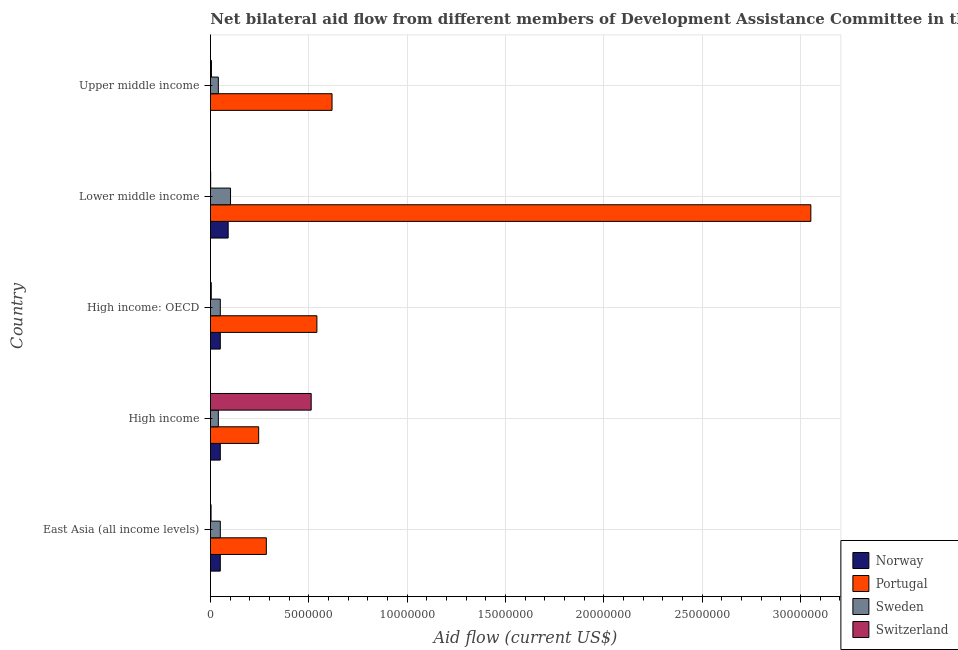Are the number of bars on each tick of the Y-axis equal?
Provide a short and direct response. No. What is the label of the 1st group of bars from the top?
Provide a short and direct response. Upper middle income. What is the amount of aid given by norway in East Asia (all income levels)?
Ensure brevity in your answer.  5.00e+05. Across all countries, what is the maximum amount of aid given by norway?
Your answer should be compact. 9.00e+05. Across all countries, what is the minimum amount of aid given by portugal?
Ensure brevity in your answer.  2.45e+06. In which country was the amount of aid given by sweden maximum?
Your answer should be compact. Lower middle income. What is the total amount of aid given by switzerland in the graph?
Ensure brevity in your answer.  5.25e+06. What is the difference between the amount of aid given by switzerland in East Asia (all income levels) and that in Upper middle income?
Keep it short and to the point. -2.00e+04. What is the difference between the amount of aid given by portugal in East Asia (all income levels) and the amount of aid given by sweden in Lower middle income?
Provide a succinct answer. 1.82e+06. What is the average amount of aid given by portugal per country?
Offer a very short reply. 9.48e+06. What is the difference between the amount of aid given by switzerland and amount of aid given by portugal in Upper middle income?
Your answer should be compact. -6.13e+06. What is the ratio of the amount of aid given by sweden in Lower middle income to that in Upper middle income?
Keep it short and to the point. 2.55. What is the difference between the highest and the second highest amount of aid given by norway?
Provide a short and direct response. 4.00e+05. What is the difference between the highest and the lowest amount of aid given by sweden?
Offer a terse response. 6.20e+05. Is the sum of the amount of aid given by switzerland in Lower middle income and Upper middle income greater than the maximum amount of aid given by sweden across all countries?
Provide a succinct answer. No. Is it the case that in every country, the sum of the amount of aid given by norway and amount of aid given by portugal is greater than the amount of aid given by sweden?
Give a very brief answer. Yes. What is the difference between two consecutive major ticks on the X-axis?
Give a very brief answer. 5.00e+06. Are the values on the major ticks of X-axis written in scientific E-notation?
Give a very brief answer. No. Does the graph contain any zero values?
Provide a short and direct response. Yes. How many legend labels are there?
Make the answer very short. 4. How are the legend labels stacked?
Offer a very short reply. Vertical. What is the title of the graph?
Your answer should be compact. Net bilateral aid flow from different members of Development Assistance Committee in the year 1961. What is the label or title of the X-axis?
Provide a succinct answer. Aid flow (current US$). What is the label or title of the Y-axis?
Your response must be concise. Country. What is the Aid flow (current US$) of Norway in East Asia (all income levels)?
Your answer should be very brief. 5.00e+05. What is the Aid flow (current US$) in Portugal in East Asia (all income levels)?
Make the answer very short. 2.84e+06. What is the Aid flow (current US$) in Sweden in East Asia (all income levels)?
Ensure brevity in your answer.  5.00e+05. What is the Aid flow (current US$) of Switzerland in East Asia (all income levels)?
Keep it short and to the point. 3.00e+04. What is the Aid flow (current US$) in Portugal in High income?
Your response must be concise. 2.45e+06. What is the Aid flow (current US$) of Sweden in High income?
Your answer should be compact. 4.00e+05. What is the Aid flow (current US$) of Switzerland in High income?
Give a very brief answer. 5.12e+06. What is the Aid flow (current US$) in Norway in High income: OECD?
Provide a succinct answer. 5.00e+05. What is the Aid flow (current US$) of Portugal in High income: OECD?
Your answer should be compact. 5.41e+06. What is the Aid flow (current US$) of Norway in Lower middle income?
Ensure brevity in your answer.  9.00e+05. What is the Aid flow (current US$) of Portugal in Lower middle income?
Make the answer very short. 3.05e+07. What is the Aid flow (current US$) of Sweden in Lower middle income?
Make the answer very short. 1.02e+06. What is the Aid flow (current US$) of Switzerland in Lower middle income?
Offer a very short reply. 10000. What is the Aid flow (current US$) of Norway in Upper middle income?
Offer a terse response. 0. What is the Aid flow (current US$) of Portugal in Upper middle income?
Offer a very short reply. 6.18e+06. What is the Aid flow (current US$) in Switzerland in Upper middle income?
Your answer should be very brief. 5.00e+04. Across all countries, what is the maximum Aid flow (current US$) in Portugal?
Provide a short and direct response. 3.05e+07. Across all countries, what is the maximum Aid flow (current US$) in Sweden?
Provide a succinct answer. 1.02e+06. Across all countries, what is the maximum Aid flow (current US$) of Switzerland?
Provide a short and direct response. 5.12e+06. Across all countries, what is the minimum Aid flow (current US$) in Norway?
Provide a succinct answer. 0. Across all countries, what is the minimum Aid flow (current US$) of Portugal?
Ensure brevity in your answer.  2.45e+06. What is the total Aid flow (current US$) in Norway in the graph?
Provide a succinct answer. 2.40e+06. What is the total Aid flow (current US$) of Portugal in the graph?
Provide a short and direct response. 4.74e+07. What is the total Aid flow (current US$) of Sweden in the graph?
Keep it short and to the point. 2.82e+06. What is the total Aid flow (current US$) in Switzerland in the graph?
Keep it short and to the point. 5.25e+06. What is the difference between the Aid flow (current US$) of Norway in East Asia (all income levels) and that in High income?
Make the answer very short. 0. What is the difference between the Aid flow (current US$) of Sweden in East Asia (all income levels) and that in High income?
Your response must be concise. 1.00e+05. What is the difference between the Aid flow (current US$) in Switzerland in East Asia (all income levels) and that in High income?
Ensure brevity in your answer.  -5.09e+06. What is the difference between the Aid flow (current US$) of Norway in East Asia (all income levels) and that in High income: OECD?
Your answer should be compact. 0. What is the difference between the Aid flow (current US$) of Portugal in East Asia (all income levels) and that in High income: OECD?
Provide a short and direct response. -2.57e+06. What is the difference between the Aid flow (current US$) in Switzerland in East Asia (all income levels) and that in High income: OECD?
Your answer should be very brief. -10000. What is the difference between the Aid flow (current US$) of Norway in East Asia (all income levels) and that in Lower middle income?
Provide a succinct answer. -4.00e+05. What is the difference between the Aid flow (current US$) in Portugal in East Asia (all income levels) and that in Lower middle income?
Keep it short and to the point. -2.77e+07. What is the difference between the Aid flow (current US$) of Sweden in East Asia (all income levels) and that in Lower middle income?
Your answer should be very brief. -5.20e+05. What is the difference between the Aid flow (current US$) of Switzerland in East Asia (all income levels) and that in Lower middle income?
Provide a succinct answer. 2.00e+04. What is the difference between the Aid flow (current US$) in Portugal in East Asia (all income levels) and that in Upper middle income?
Offer a terse response. -3.34e+06. What is the difference between the Aid flow (current US$) of Sweden in East Asia (all income levels) and that in Upper middle income?
Keep it short and to the point. 1.00e+05. What is the difference between the Aid flow (current US$) of Norway in High income and that in High income: OECD?
Give a very brief answer. 0. What is the difference between the Aid flow (current US$) in Portugal in High income and that in High income: OECD?
Offer a very short reply. -2.96e+06. What is the difference between the Aid flow (current US$) in Switzerland in High income and that in High income: OECD?
Offer a terse response. 5.08e+06. What is the difference between the Aid flow (current US$) in Norway in High income and that in Lower middle income?
Your answer should be compact. -4.00e+05. What is the difference between the Aid flow (current US$) of Portugal in High income and that in Lower middle income?
Give a very brief answer. -2.81e+07. What is the difference between the Aid flow (current US$) of Sweden in High income and that in Lower middle income?
Your response must be concise. -6.20e+05. What is the difference between the Aid flow (current US$) of Switzerland in High income and that in Lower middle income?
Give a very brief answer. 5.11e+06. What is the difference between the Aid flow (current US$) in Portugal in High income and that in Upper middle income?
Keep it short and to the point. -3.73e+06. What is the difference between the Aid flow (current US$) in Switzerland in High income and that in Upper middle income?
Provide a succinct answer. 5.07e+06. What is the difference between the Aid flow (current US$) in Norway in High income: OECD and that in Lower middle income?
Provide a short and direct response. -4.00e+05. What is the difference between the Aid flow (current US$) of Portugal in High income: OECD and that in Lower middle income?
Your answer should be very brief. -2.51e+07. What is the difference between the Aid flow (current US$) of Sweden in High income: OECD and that in Lower middle income?
Provide a succinct answer. -5.20e+05. What is the difference between the Aid flow (current US$) in Switzerland in High income: OECD and that in Lower middle income?
Your response must be concise. 3.00e+04. What is the difference between the Aid flow (current US$) of Portugal in High income: OECD and that in Upper middle income?
Offer a terse response. -7.70e+05. What is the difference between the Aid flow (current US$) of Portugal in Lower middle income and that in Upper middle income?
Your answer should be very brief. 2.43e+07. What is the difference between the Aid flow (current US$) in Sweden in Lower middle income and that in Upper middle income?
Your answer should be compact. 6.20e+05. What is the difference between the Aid flow (current US$) of Switzerland in Lower middle income and that in Upper middle income?
Provide a short and direct response. -4.00e+04. What is the difference between the Aid flow (current US$) of Norway in East Asia (all income levels) and the Aid flow (current US$) of Portugal in High income?
Keep it short and to the point. -1.95e+06. What is the difference between the Aid flow (current US$) of Norway in East Asia (all income levels) and the Aid flow (current US$) of Switzerland in High income?
Make the answer very short. -4.62e+06. What is the difference between the Aid flow (current US$) of Portugal in East Asia (all income levels) and the Aid flow (current US$) of Sweden in High income?
Offer a very short reply. 2.44e+06. What is the difference between the Aid flow (current US$) in Portugal in East Asia (all income levels) and the Aid flow (current US$) in Switzerland in High income?
Your answer should be very brief. -2.28e+06. What is the difference between the Aid flow (current US$) of Sweden in East Asia (all income levels) and the Aid flow (current US$) of Switzerland in High income?
Your answer should be compact. -4.62e+06. What is the difference between the Aid flow (current US$) in Norway in East Asia (all income levels) and the Aid flow (current US$) in Portugal in High income: OECD?
Offer a very short reply. -4.91e+06. What is the difference between the Aid flow (current US$) of Norway in East Asia (all income levels) and the Aid flow (current US$) of Sweden in High income: OECD?
Make the answer very short. 0. What is the difference between the Aid flow (current US$) in Norway in East Asia (all income levels) and the Aid flow (current US$) in Switzerland in High income: OECD?
Your answer should be very brief. 4.60e+05. What is the difference between the Aid flow (current US$) of Portugal in East Asia (all income levels) and the Aid flow (current US$) of Sweden in High income: OECD?
Keep it short and to the point. 2.34e+06. What is the difference between the Aid flow (current US$) of Portugal in East Asia (all income levels) and the Aid flow (current US$) of Switzerland in High income: OECD?
Keep it short and to the point. 2.80e+06. What is the difference between the Aid flow (current US$) of Norway in East Asia (all income levels) and the Aid flow (current US$) of Portugal in Lower middle income?
Provide a short and direct response. -3.00e+07. What is the difference between the Aid flow (current US$) in Norway in East Asia (all income levels) and the Aid flow (current US$) in Sweden in Lower middle income?
Make the answer very short. -5.20e+05. What is the difference between the Aid flow (current US$) of Norway in East Asia (all income levels) and the Aid flow (current US$) of Switzerland in Lower middle income?
Provide a short and direct response. 4.90e+05. What is the difference between the Aid flow (current US$) in Portugal in East Asia (all income levels) and the Aid flow (current US$) in Sweden in Lower middle income?
Give a very brief answer. 1.82e+06. What is the difference between the Aid flow (current US$) in Portugal in East Asia (all income levels) and the Aid flow (current US$) in Switzerland in Lower middle income?
Keep it short and to the point. 2.83e+06. What is the difference between the Aid flow (current US$) in Sweden in East Asia (all income levels) and the Aid flow (current US$) in Switzerland in Lower middle income?
Your response must be concise. 4.90e+05. What is the difference between the Aid flow (current US$) in Norway in East Asia (all income levels) and the Aid flow (current US$) in Portugal in Upper middle income?
Give a very brief answer. -5.68e+06. What is the difference between the Aid flow (current US$) in Portugal in East Asia (all income levels) and the Aid flow (current US$) in Sweden in Upper middle income?
Your answer should be very brief. 2.44e+06. What is the difference between the Aid flow (current US$) of Portugal in East Asia (all income levels) and the Aid flow (current US$) of Switzerland in Upper middle income?
Offer a very short reply. 2.79e+06. What is the difference between the Aid flow (current US$) in Norway in High income and the Aid flow (current US$) in Portugal in High income: OECD?
Make the answer very short. -4.91e+06. What is the difference between the Aid flow (current US$) of Norway in High income and the Aid flow (current US$) of Sweden in High income: OECD?
Give a very brief answer. 0. What is the difference between the Aid flow (current US$) in Norway in High income and the Aid flow (current US$) in Switzerland in High income: OECD?
Provide a succinct answer. 4.60e+05. What is the difference between the Aid flow (current US$) of Portugal in High income and the Aid flow (current US$) of Sweden in High income: OECD?
Provide a short and direct response. 1.95e+06. What is the difference between the Aid flow (current US$) of Portugal in High income and the Aid flow (current US$) of Switzerland in High income: OECD?
Offer a very short reply. 2.41e+06. What is the difference between the Aid flow (current US$) in Norway in High income and the Aid flow (current US$) in Portugal in Lower middle income?
Ensure brevity in your answer.  -3.00e+07. What is the difference between the Aid flow (current US$) in Norway in High income and the Aid flow (current US$) in Sweden in Lower middle income?
Keep it short and to the point. -5.20e+05. What is the difference between the Aid flow (current US$) of Norway in High income and the Aid flow (current US$) of Switzerland in Lower middle income?
Your answer should be very brief. 4.90e+05. What is the difference between the Aid flow (current US$) in Portugal in High income and the Aid flow (current US$) in Sweden in Lower middle income?
Provide a short and direct response. 1.43e+06. What is the difference between the Aid flow (current US$) of Portugal in High income and the Aid flow (current US$) of Switzerland in Lower middle income?
Provide a short and direct response. 2.44e+06. What is the difference between the Aid flow (current US$) in Sweden in High income and the Aid flow (current US$) in Switzerland in Lower middle income?
Provide a short and direct response. 3.90e+05. What is the difference between the Aid flow (current US$) in Norway in High income and the Aid flow (current US$) in Portugal in Upper middle income?
Give a very brief answer. -5.68e+06. What is the difference between the Aid flow (current US$) in Norway in High income and the Aid flow (current US$) in Sweden in Upper middle income?
Your response must be concise. 1.00e+05. What is the difference between the Aid flow (current US$) in Norway in High income and the Aid flow (current US$) in Switzerland in Upper middle income?
Your answer should be very brief. 4.50e+05. What is the difference between the Aid flow (current US$) of Portugal in High income and the Aid flow (current US$) of Sweden in Upper middle income?
Your answer should be very brief. 2.05e+06. What is the difference between the Aid flow (current US$) in Portugal in High income and the Aid flow (current US$) in Switzerland in Upper middle income?
Your answer should be compact. 2.40e+06. What is the difference between the Aid flow (current US$) of Sweden in High income and the Aid flow (current US$) of Switzerland in Upper middle income?
Your answer should be very brief. 3.50e+05. What is the difference between the Aid flow (current US$) of Norway in High income: OECD and the Aid flow (current US$) of Portugal in Lower middle income?
Ensure brevity in your answer.  -3.00e+07. What is the difference between the Aid flow (current US$) of Norway in High income: OECD and the Aid flow (current US$) of Sweden in Lower middle income?
Offer a very short reply. -5.20e+05. What is the difference between the Aid flow (current US$) of Portugal in High income: OECD and the Aid flow (current US$) of Sweden in Lower middle income?
Ensure brevity in your answer.  4.39e+06. What is the difference between the Aid flow (current US$) of Portugal in High income: OECD and the Aid flow (current US$) of Switzerland in Lower middle income?
Your answer should be very brief. 5.40e+06. What is the difference between the Aid flow (current US$) of Sweden in High income: OECD and the Aid flow (current US$) of Switzerland in Lower middle income?
Offer a very short reply. 4.90e+05. What is the difference between the Aid flow (current US$) in Norway in High income: OECD and the Aid flow (current US$) in Portugal in Upper middle income?
Keep it short and to the point. -5.68e+06. What is the difference between the Aid flow (current US$) in Norway in High income: OECD and the Aid flow (current US$) in Sweden in Upper middle income?
Your answer should be very brief. 1.00e+05. What is the difference between the Aid flow (current US$) in Portugal in High income: OECD and the Aid flow (current US$) in Sweden in Upper middle income?
Make the answer very short. 5.01e+06. What is the difference between the Aid flow (current US$) in Portugal in High income: OECD and the Aid flow (current US$) in Switzerland in Upper middle income?
Make the answer very short. 5.36e+06. What is the difference between the Aid flow (current US$) in Norway in Lower middle income and the Aid flow (current US$) in Portugal in Upper middle income?
Your response must be concise. -5.28e+06. What is the difference between the Aid flow (current US$) in Norway in Lower middle income and the Aid flow (current US$) in Switzerland in Upper middle income?
Your answer should be compact. 8.50e+05. What is the difference between the Aid flow (current US$) of Portugal in Lower middle income and the Aid flow (current US$) of Sweden in Upper middle income?
Keep it short and to the point. 3.01e+07. What is the difference between the Aid flow (current US$) in Portugal in Lower middle income and the Aid flow (current US$) in Switzerland in Upper middle income?
Provide a short and direct response. 3.05e+07. What is the difference between the Aid flow (current US$) in Sweden in Lower middle income and the Aid flow (current US$) in Switzerland in Upper middle income?
Provide a succinct answer. 9.70e+05. What is the average Aid flow (current US$) in Portugal per country?
Offer a very short reply. 9.48e+06. What is the average Aid flow (current US$) of Sweden per country?
Provide a short and direct response. 5.64e+05. What is the average Aid flow (current US$) of Switzerland per country?
Ensure brevity in your answer.  1.05e+06. What is the difference between the Aid flow (current US$) in Norway and Aid flow (current US$) in Portugal in East Asia (all income levels)?
Make the answer very short. -2.34e+06. What is the difference between the Aid flow (current US$) in Norway and Aid flow (current US$) in Switzerland in East Asia (all income levels)?
Make the answer very short. 4.70e+05. What is the difference between the Aid flow (current US$) of Portugal and Aid flow (current US$) of Sweden in East Asia (all income levels)?
Provide a succinct answer. 2.34e+06. What is the difference between the Aid flow (current US$) in Portugal and Aid flow (current US$) in Switzerland in East Asia (all income levels)?
Your answer should be very brief. 2.81e+06. What is the difference between the Aid flow (current US$) in Sweden and Aid flow (current US$) in Switzerland in East Asia (all income levels)?
Keep it short and to the point. 4.70e+05. What is the difference between the Aid flow (current US$) in Norway and Aid flow (current US$) in Portugal in High income?
Offer a very short reply. -1.95e+06. What is the difference between the Aid flow (current US$) of Norway and Aid flow (current US$) of Switzerland in High income?
Your response must be concise. -4.62e+06. What is the difference between the Aid flow (current US$) of Portugal and Aid flow (current US$) of Sweden in High income?
Your answer should be compact. 2.05e+06. What is the difference between the Aid flow (current US$) in Portugal and Aid flow (current US$) in Switzerland in High income?
Give a very brief answer. -2.67e+06. What is the difference between the Aid flow (current US$) of Sweden and Aid flow (current US$) of Switzerland in High income?
Your answer should be compact. -4.72e+06. What is the difference between the Aid flow (current US$) in Norway and Aid flow (current US$) in Portugal in High income: OECD?
Provide a succinct answer. -4.91e+06. What is the difference between the Aid flow (current US$) of Norway and Aid flow (current US$) of Switzerland in High income: OECD?
Make the answer very short. 4.60e+05. What is the difference between the Aid flow (current US$) in Portugal and Aid flow (current US$) in Sweden in High income: OECD?
Your answer should be very brief. 4.91e+06. What is the difference between the Aid flow (current US$) of Portugal and Aid flow (current US$) of Switzerland in High income: OECD?
Offer a terse response. 5.37e+06. What is the difference between the Aid flow (current US$) of Sweden and Aid flow (current US$) of Switzerland in High income: OECD?
Offer a terse response. 4.60e+05. What is the difference between the Aid flow (current US$) of Norway and Aid flow (current US$) of Portugal in Lower middle income?
Provide a short and direct response. -2.96e+07. What is the difference between the Aid flow (current US$) in Norway and Aid flow (current US$) in Switzerland in Lower middle income?
Give a very brief answer. 8.90e+05. What is the difference between the Aid flow (current US$) of Portugal and Aid flow (current US$) of Sweden in Lower middle income?
Your answer should be very brief. 2.95e+07. What is the difference between the Aid flow (current US$) of Portugal and Aid flow (current US$) of Switzerland in Lower middle income?
Your response must be concise. 3.05e+07. What is the difference between the Aid flow (current US$) of Sweden and Aid flow (current US$) of Switzerland in Lower middle income?
Make the answer very short. 1.01e+06. What is the difference between the Aid flow (current US$) in Portugal and Aid flow (current US$) in Sweden in Upper middle income?
Provide a short and direct response. 5.78e+06. What is the difference between the Aid flow (current US$) of Portugal and Aid flow (current US$) of Switzerland in Upper middle income?
Your answer should be compact. 6.13e+06. What is the ratio of the Aid flow (current US$) in Norway in East Asia (all income levels) to that in High income?
Your answer should be very brief. 1. What is the ratio of the Aid flow (current US$) in Portugal in East Asia (all income levels) to that in High income?
Make the answer very short. 1.16. What is the ratio of the Aid flow (current US$) of Sweden in East Asia (all income levels) to that in High income?
Your answer should be compact. 1.25. What is the ratio of the Aid flow (current US$) in Switzerland in East Asia (all income levels) to that in High income?
Provide a short and direct response. 0.01. What is the ratio of the Aid flow (current US$) in Norway in East Asia (all income levels) to that in High income: OECD?
Provide a short and direct response. 1. What is the ratio of the Aid flow (current US$) of Portugal in East Asia (all income levels) to that in High income: OECD?
Provide a short and direct response. 0.53. What is the ratio of the Aid flow (current US$) of Sweden in East Asia (all income levels) to that in High income: OECD?
Keep it short and to the point. 1. What is the ratio of the Aid flow (current US$) in Norway in East Asia (all income levels) to that in Lower middle income?
Your response must be concise. 0.56. What is the ratio of the Aid flow (current US$) of Portugal in East Asia (all income levels) to that in Lower middle income?
Your answer should be very brief. 0.09. What is the ratio of the Aid flow (current US$) of Sweden in East Asia (all income levels) to that in Lower middle income?
Ensure brevity in your answer.  0.49. What is the ratio of the Aid flow (current US$) in Portugal in East Asia (all income levels) to that in Upper middle income?
Keep it short and to the point. 0.46. What is the ratio of the Aid flow (current US$) of Switzerland in East Asia (all income levels) to that in Upper middle income?
Provide a short and direct response. 0.6. What is the ratio of the Aid flow (current US$) in Portugal in High income to that in High income: OECD?
Provide a short and direct response. 0.45. What is the ratio of the Aid flow (current US$) of Switzerland in High income to that in High income: OECD?
Your answer should be compact. 128. What is the ratio of the Aid flow (current US$) of Norway in High income to that in Lower middle income?
Offer a very short reply. 0.56. What is the ratio of the Aid flow (current US$) of Portugal in High income to that in Lower middle income?
Offer a terse response. 0.08. What is the ratio of the Aid flow (current US$) of Sweden in High income to that in Lower middle income?
Keep it short and to the point. 0.39. What is the ratio of the Aid flow (current US$) in Switzerland in High income to that in Lower middle income?
Offer a terse response. 512. What is the ratio of the Aid flow (current US$) in Portugal in High income to that in Upper middle income?
Your response must be concise. 0.4. What is the ratio of the Aid flow (current US$) in Switzerland in High income to that in Upper middle income?
Keep it short and to the point. 102.4. What is the ratio of the Aid flow (current US$) of Norway in High income: OECD to that in Lower middle income?
Your answer should be very brief. 0.56. What is the ratio of the Aid flow (current US$) in Portugal in High income: OECD to that in Lower middle income?
Keep it short and to the point. 0.18. What is the ratio of the Aid flow (current US$) in Sweden in High income: OECD to that in Lower middle income?
Make the answer very short. 0.49. What is the ratio of the Aid flow (current US$) of Switzerland in High income: OECD to that in Lower middle income?
Your answer should be very brief. 4. What is the ratio of the Aid flow (current US$) in Portugal in High income: OECD to that in Upper middle income?
Your answer should be very brief. 0.88. What is the ratio of the Aid flow (current US$) in Sweden in High income: OECD to that in Upper middle income?
Your answer should be compact. 1.25. What is the ratio of the Aid flow (current US$) in Portugal in Lower middle income to that in Upper middle income?
Ensure brevity in your answer.  4.94. What is the ratio of the Aid flow (current US$) in Sweden in Lower middle income to that in Upper middle income?
Offer a very short reply. 2.55. What is the difference between the highest and the second highest Aid flow (current US$) of Portugal?
Provide a succinct answer. 2.43e+07. What is the difference between the highest and the second highest Aid flow (current US$) in Sweden?
Offer a terse response. 5.20e+05. What is the difference between the highest and the second highest Aid flow (current US$) of Switzerland?
Provide a short and direct response. 5.07e+06. What is the difference between the highest and the lowest Aid flow (current US$) in Portugal?
Offer a terse response. 2.81e+07. What is the difference between the highest and the lowest Aid flow (current US$) in Sweden?
Make the answer very short. 6.20e+05. What is the difference between the highest and the lowest Aid flow (current US$) in Switzerland?
Give a very brief answer. 5.11e+06. 